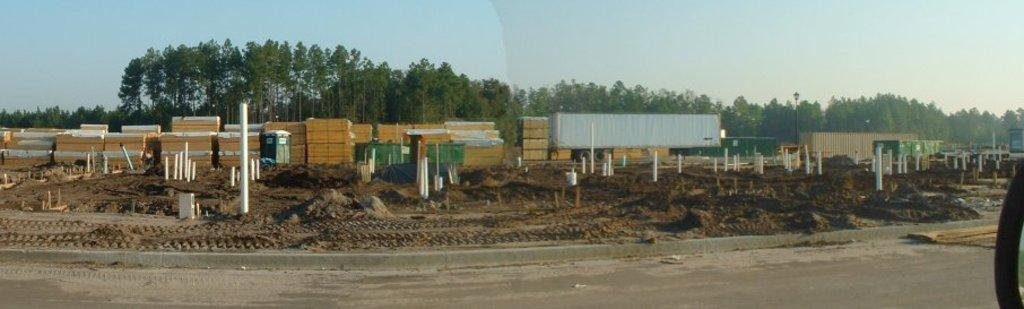What is located at the center of the image? There are objects at the center of the image. What can be seen on the surface of the sand? There are rods placed on the surface of the sand. What type of vegetation is visible in the background of the image? There are trees in the background of the image. What is visible in the farthest away in the image? The sky is visible in the background of the image. What type of lawyer is present in the image? There is no lawyer present in the image. What is the cause of the steel objects in the image? There are no steel objects present in the image. 